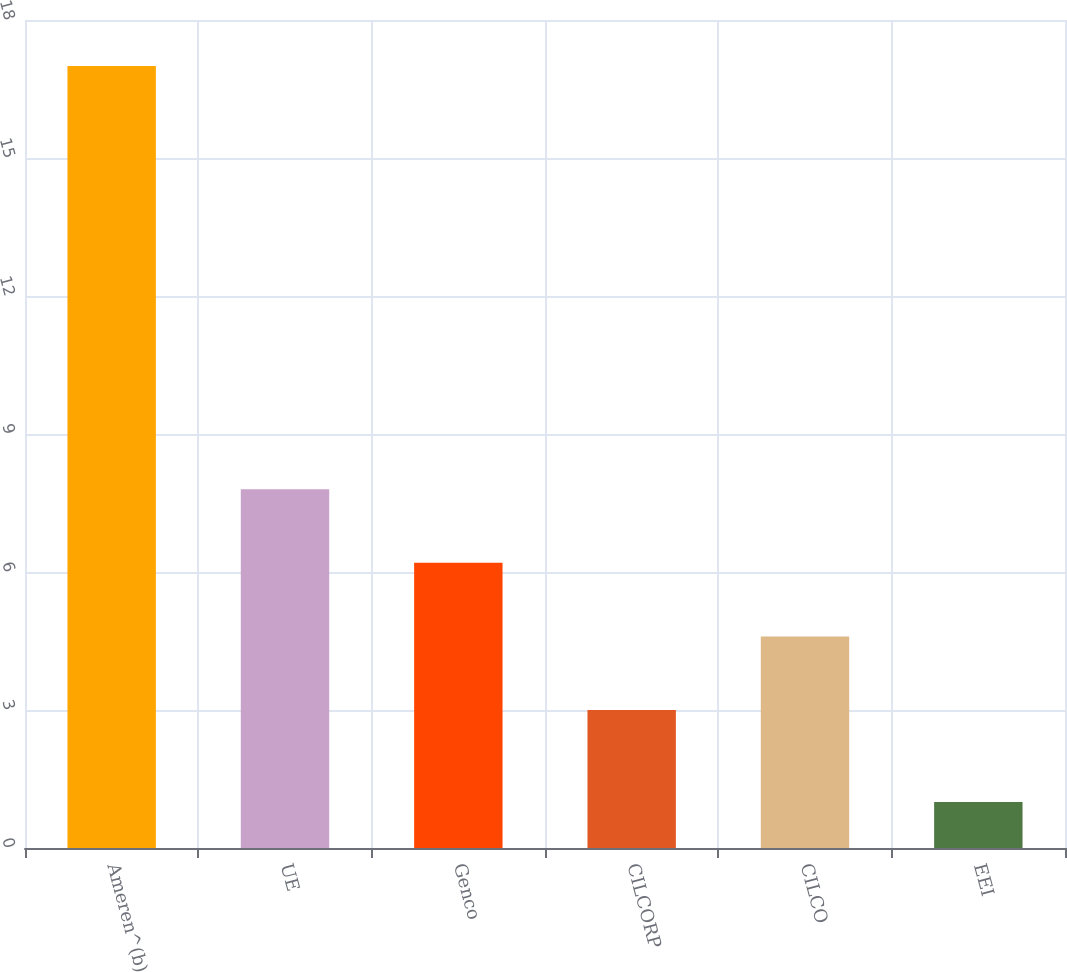<chart> <loc_0><loc_0><loc_500><loc_500><bar_chart><fcel>Ameren^(b)<fcel>UE<fcel>Genco<fcel>CILCORP<fcel>CILCO<fcel>EEI<nl><fcel>17<fcel>7.8<fcel>6.2<fcel>3<fcel>4.6<fcel>1<nl></chart> 